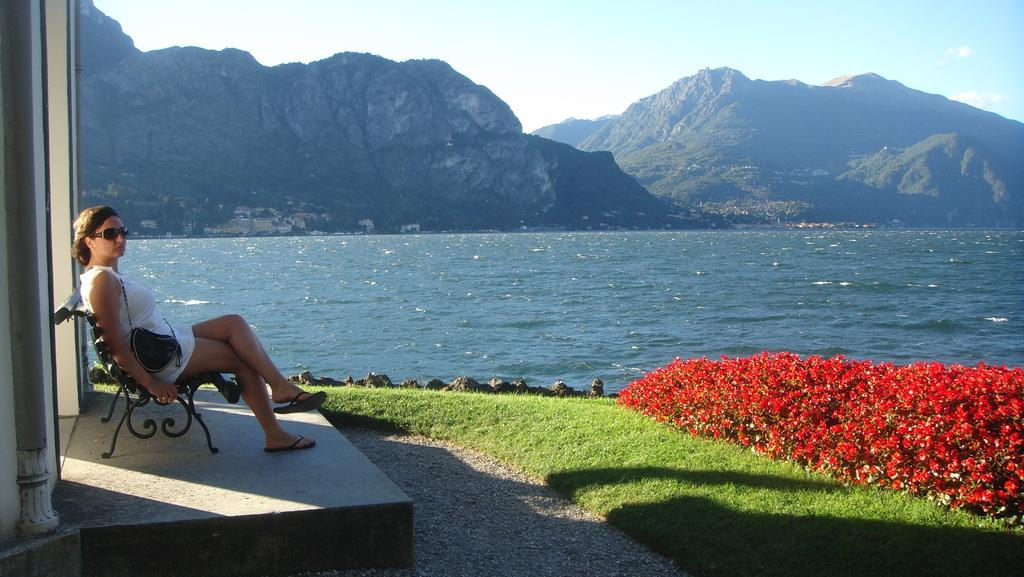What is the person in the image doing? There is a person sitting on a bench in the image. What type of vegetation can be seen in the image? There are flowers and grass in the image. What body of water is present in the image? There is water in the image. What geographical feature is visible in the distance? There are mountains in the image. What can be seen in the background of the image? The sky is visible in the background of the image. How many dolls are sitting on the stranger's lap in the image? There is no stranger or doll present in the image. 